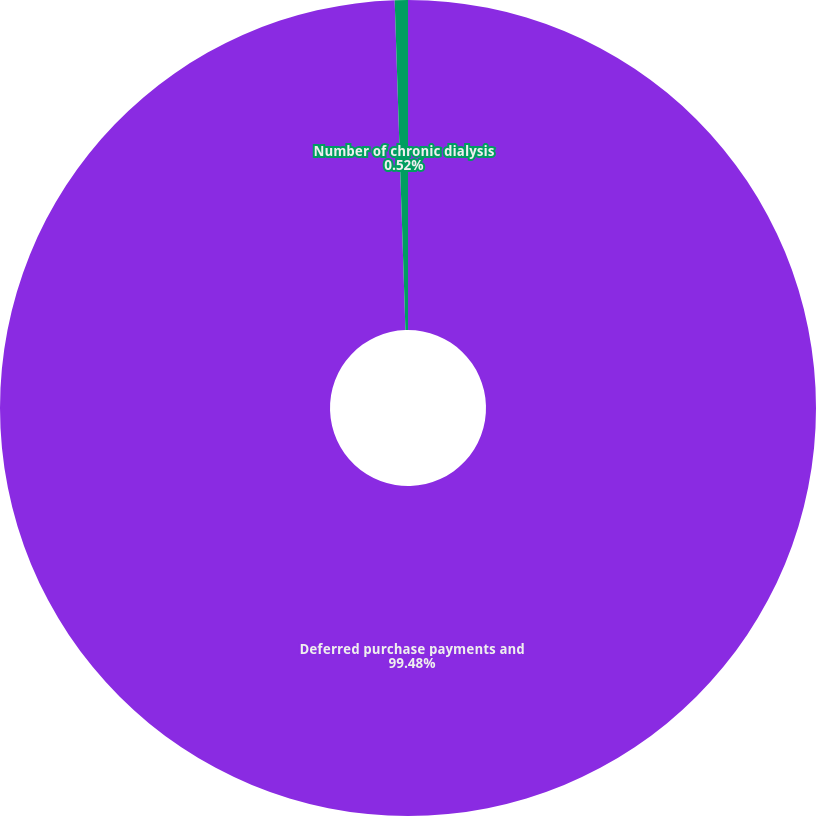Convert chart. <chart><loc_0><loc_0><loc_500><loc_500><pie_chart><fcel>Deferred purchase payments and<fcel>Number of chronic dialysis<nl><fcel>99.48%<fcel>0.52%<nl></chart> 